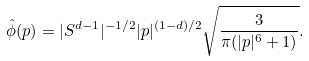Convert formula to latex. <formula><loc_0><loc_0><loc_500><loc_500>\hat { \phi } ( p ) = | S ^ { d - 1 } | ^ { - { 1 } / { 2 } } | p | ^ { ( 1 - d ) / { 2 } } \sqrt { \frac { 3 } { \pi ( | p | ^ { 6 } + 1 ) } } .</formula> 